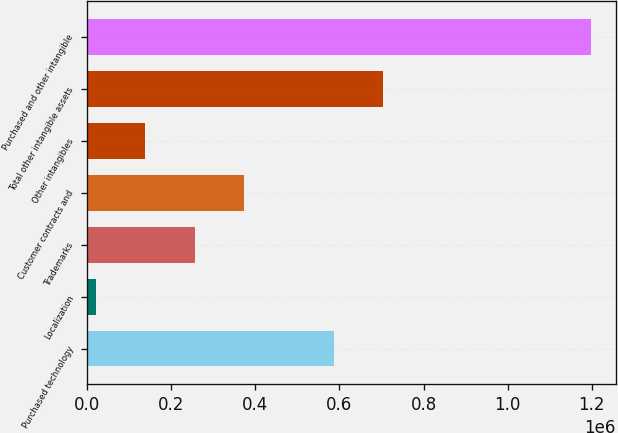<chart> <loc_0><loc_0><loc_500><loc_500><bar_chart><fcel>Purchased technology<fcel>Localization<fcel>Trademarks<fcel>Customer contracts and<fcel>Other intangibles<fcel>Total other intangible assets<fcel>Purchased and other intangible<nl><fcel>586952<fcel>20284<fcel>255772<fcel>373516<fcel>138028<fcel>704696<fcel>1.19772e+06<nl></chart> 